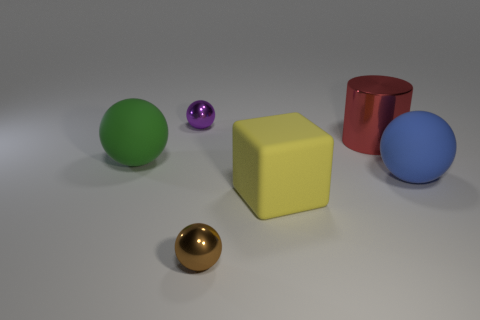Add 2 big blue matte balls. How many objects exist? 8 Subtract 2 spheres. How many spheres are left? 2 Subtract all brown spheres. How many spheres are left? 3 Subtract all green balls. How many balls are left? 3 Subtract all balls. How many objects are left? 2 Subtract all green spheres. Subtract all red blocks. How many spheres are left? 3 Subtract all large yellow balls. Subtract all blue rubber balls. How many objects are left? 5 Add 5 cylinders. How many cylinders are left? 6 Add 3 cylinders. How many cylinders exist? 4 Subtract 1 brown balls. How many objects are left? 5 